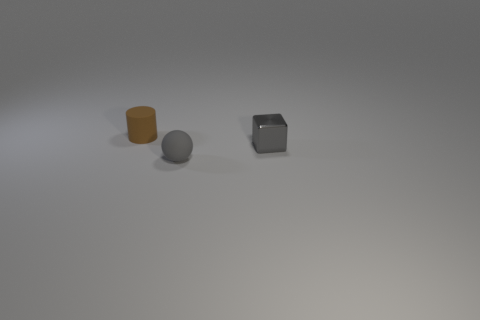Add 3 tiny yellow balls. How many objects exist? 6 Subtract all cubes. How many objects are left? 2 Add 2 small yellow balls. How many small yellow balls exist? 2 Subtract 0 brown blocks. How many objects are left? 3 Subtract all red matte things. Subtract all cylinders. How many objects are left? 2 Add 2 brown things. How many brown things are left? 3 